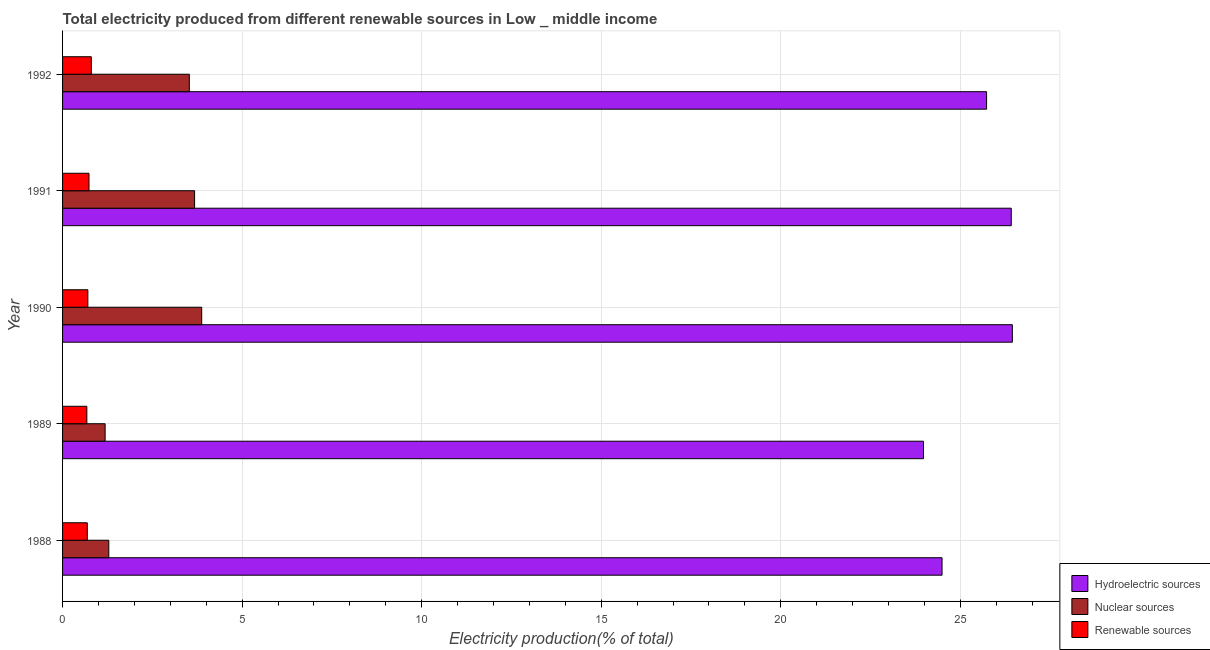How many bars are there on the 1st tick from the top?
Make the answer very short. 3. In how many cases, is the number of bars for a given year not equal to the number of legend labels?
Your answer should be very brief. 0. What is the percentage of electricity produced by hydroelectric sources in 1991?
Give a very brief answer. 26.42. Across all years, what is the maximum percentage of electricity produced by hydroelectric sources?
Keep it short and to the point. 26.45. Across all years, what is the minimum percentage of electricity produced by hydroelectric sources?
Offer a terse response. 23.98. What is the total percentage of electricity produced by hydroelectric sources in the graph?
Ensure brevity in your answer.  127.07. What is the difference between the percentage of electricity produced by nuclear sources in 1988 and that in 1992?
Offer a very short reply. -2.24. What is the difference between the percentage of electricity produced by nuclear sources in 1991 and the percentage of electricity produced by hydroelectric sources in 1988?
Provide a short and direct response. -20.82. What is the average percentage of electricity produced by hydroelectric sources per year?
Offer a very short reply. 25.41. In the year 1992, what is the difference between the percentage of electricity produced by hydroelectric sources and percentage of electricity produced by nuclear sources?
Your answer should be compact. 22.2. In how many years, is the percentage of electricity produced by nuclear sources greater than 15 %?
Offer a terse response. 0. What is the ratio of the percentage of electricity produced by nuclear sources in 1988 to that in 1991?
Give a very brief answer. 0.35. What is the difference between the highest and the second highest percentage of electricity produced by nuclear sources?
Your answer should be compact. 0.2. What is the difference between the highest and the lowest percentage of electricity produced by renewable sources?
Offer a very short reply. 0.12. In how many years, is the percentage of electricity produced by hydroelectric sources greater than the average percentage of electricity produced by hydroelectric sources taken over all years?
Give a very brief answer. 3. Is the sum of the percentage of electricity produced by renewable sources in 1990 and 1992 greater than the maximum percentage of electricity produced by nuclear sources across all years?
Provide a short and direct response. No. What does the 3rd bar from the top in 1990 represents?
Provide a short and direct response. Hydroelectric sources. What does the 2nd bar from the bottom in 1988 represents?
Offer a very short reply. Nuclear sources. Are all the bars in the graph horizontal?
Offer a very short reply. Yes. Are the values on the major ticks of X-axis written in scientific E-notation?
Offer a terse response. No. Does the graph contain any zero values?
Keep it short and to the point. No. Does the graph contain grids?
Your answer should be very brief. Yes. Where does the legend appear in the graph?
Keep it short and to the point. Bottom right. How are the legend labels stacked?
Provide a succinct answer. Vertical. What is the title of the graph?
Offer a very short reply. Total electricity produced from different renewable sources in Low _ middle income. What is the label or title of the X-axis?
Offer a very short reply. Electricity production(% of total). What is the label or title of the Y-axis?
Offer a very short reply. Year. What is the Electricity production(% of total) in Hydroelectric sources in 1988?
Your response must be concise. 24.49. What is the Electricity production(% of total) of Nuclear sources in 1988?
Your answer should be very brief. 1.29. What is the Electricity production(% of total) in Renewable sources in 1988?
Offer a terse response. 0.69. What is the Electricity production(% of total) of Hydroelectric sources in 1989?
Give a very brief answer. 23.98. What is the Electricity production(% of total) in Nuclear sources in 1989?
Offer a terse response. 1.19. What is the Electricity production(% of total) of Renewable sources in 1989?
Your response must be concise. 0.68. What is the Electricity production(% of total) in Hydroelectric sources in 1990?
Ensure brevity in your answer.  26.45. What is the Electricity production(% of total) of Nuclear sources in 1990?
Offer a terse response. 3.87. What is the Electricity production(% of total) of Renewable sources in 1990?
Make the answer very short. 0.7. What is the Electricity production(% of total) of Hydroelectric sources in 1991?
Provide a succinct answer. 26.42. What is the Electricity production(% of total) of Nuclear sources in 1991?
Offer a very short reply. 3.68. What is the Electricity production(% of total) of Renewable sources in 1991?
Provide a short and direct response. 0.74. What is the Electricity production(% of total) in Hydroelectric sources in 1992?
Provide a succinct answer. 25.73. What is the Electricity production(% of total) in Nuclear sources in 1992?
Your answer should be very brief. 3.53. What is the Electricity production(% of total) in Renewable sources in 1992?
Your response must be concise. 0.8. Across all years, what is the maximum Electricity production(% of total) of Hydroelectric sources?
Ensure brevity in your answer.  26.45. Across all years, what is the maximum Electricity production(% of total) in Nuclear sources?
Keep it short and to the point. 3.87. Across all years, what is the maximum Electricity production(% of total) of Renewable sources?
Provide a short and direct response. 0.8. Across all years, what is the minimum Electricity production(% of total) of Hydroelectric sources?
Ensure brevity in your answer.  23.98. Across all years, what is the minimum Electricity production(% of total) of Nuclear sources?
Your answer should be very brief. 1.19. Across all years, what is the minimum Electricity production(% of total) of Renewable sources?
Your answer should be very brief. 0.68. What is the total Electricity production(% of total) in Hydroelectric sources in the graph?
Ensure brevity in your answer.  127.07. What is the total Electricity production(% of total) of Nuclear sources in the graph?
Provide a succinct answer. 13.55. What is the total Electricity production(% of total) of Renewable sources in the graph?
Offer a terse response. 3.61. What is the difference between the Electricity production(% of total) of Hydroelectric sources in 1988 and that in 1989?
Give a very brief answer. 0.52. What is the difference between the Electricity production(% of total) of Nuclear sources in 1988 and that in 1989?
Keep it short and to the point. 0.1. What is the difference between the Electricity production(% of total) in Renewable sources in 1988 and that in 1989?
Your answer should be very brief. 0.01. What is the difference between the Electricity production(% of total) of Hydroelectric sources in 1988 and that in 1990?
Make the answer very short. -1.96. What is the difference between the Electricity production(% of total) in Nuclear sources in 1988 and that in 1990?
Provide a short and direct response. -2.59. What is the difference between the Electricity production(% of total) in Renewable sources in 1988 and that in 1990?
Offer a terse response. -0.02. What is the difference between the Electricity production(% of total) of Hydroelectric sources in 1988 and that in 1991?
Your answer should be very brief. -1.93. What is the difference between the Electricity production(% of total) in Nuclear sources in 1988 and that in 1991?
Give a very brief answer. -2.39. What is the difference between the Electricity production(% of total) of Renewable sources in 1988 and that in 1991?
Provide a short and direct response. -0.05. What is the difference between the Electricity production(% of total) in Hydroelectric sources in 1988 and that in 1992?
Keep it short and to the point. -1.24. What is the difference between the Electricity production(% of total) of Nuclear sources in 1988 and that in 1992?
Provide a succinct answer. -2.24. What is the difference between the Electricity production(% of total) of Renewable sources in 1988 and that in 1992?
Keep it short and to the point. -0.11. What is the difference between the Electricity production(% of total) in Hydroelectric sources in 1989 and that in 1990?
Make the answer very short. -2.48. What is the difference between the Electricity production(% of total) of Nuclear sources in 1989 and that in 1990?
Keep it short and to the point. -2.69. What is the difference between the Electricity production(% of total) in Renewable sources in 1989 and that in 1990?
Give a very brief answer. -0.03. What is the difference between the Electricity production(% of total) in Hydroelectric sources in 1989 and that in 1991?
Offer a very short reply. -2.44. What is the difference between the Electricity production(% of total) of Nuclear sources in 1989 and that in 1991?
Your response must be concise. -2.49. What is the difference between the Electricity production(% of total) of Renewable sources in 1989 and that in 1991?
Offer a very short reply. -0.06. What is the difference between the Electricity production(% of total) of Hydroelectric sources in 1989 and that in 1992?
Offer a very short reply. -1.76. What is the difference between the Electricity production(% of total) in Nuclear sources in 1989 and that in 1992?
Make the answer very short. -2.35. What is the difference between the Electricity production(% of total) of Renewable sources in 1989 and that in 1992?
Your answer should be compact. -0.12. What is the difference between the Electricity production(% of total) in Hydroelectric sources in 1990 and that in 1991?
Make the answer very short. 0.03. What is the difference between the Electricity production(% of total) of Nuclear sources in 1990 and that in 1991?
Ensure brevity in your answer.  0.2. What is the difference between the Electricity production(% of total) of Renewable sources in 1990 and that in 1991?
Give a very brief answer. -0.03. What is the difference between the Electricity production(% of total) of Hydroelectric sources in 1990 and that in 1992?
Provide a short and direct response. 0.72. What is the difference between the Electricity production(% of total) in Nuclear sources in 1990 and that in 1992?
Provide a short and direct response. 0.34. What is the difference between the Electricity production(% of total) of Renewable sources in 1990 and that in 1992?
Ensure brevity in your answer.  -0.1. What is the difference between the Electricity production(% of total) of Hydroelectric sources in 1991 and that in 1992?
Ensure brevity in your answer.  0.69. What is the difference between the Electricity production(% of total) of Nuclear sources in 1991 and that in 1992?
Provide a short and direct response. 0.15. What is the difference between the Electricity production(% of total) of Renewable sources in 1991 and that in 1992?
Provide a short and direct response. -0.06. What is the difference between the Electricity production(% of total) of Hydroelectric sources in 1988 and the Electricity production(% of total) of Nuclear sources in 1989?
Ensure brevity in your answer.  23.31. What is the difference between the Electricity production(% of total) in Hydroelectric sources in 1988 and the Electricity production(% of total) in Renewable sources in 1989?
Provide a short and direct response. 23.82. What is the difference between the Electricity production(% of total) in Nuclear sources in 1988 and the Electricity production(% of total) in Renewable sources in 1989?
Give a very brief answer. 0.61. What is the difference between the Electricity production(% of total) in Hydroelectric sources in 1988 and the Electricity production(% of total) in Nuclear sources in 1990?
Give a very brief answer. 20.62. What is the difference between the Electricity production(% of total) of Hydroelectric sources in 1988 and the Electricity production(% of total) of Renewable sources in 1990?
Ensure brevity in your answer.  23.79. What is the difference between the Electricity production(% of total) of Nuclear sources in 1988 and the Electricity production(% of total) of Renewable sources in 1990?
Make the answer very short. 0.58. What is the difference between the Electricity production(% of total) of Hydroelectric sources in 1988 and the Electricity production(% of total) of Nuclear sources in 1991?
Keep it short and to the point. 20.82. What is the difference between the Electricity production(% of total) of Hydroelectric sources in 1988 and the Electricity production(% of total) of Renewable sources in 1991?
Your answer should be compact. 23.76. What is the difference between the Electricity production(% of total) in Nuclear sources in 1988 and the Electricity production(% of total) in Renewable sources in 1991?
Make the answer very short. 0.55. What is the difference between the Electricity production(% of total) in Hydroelectric sources in 1988 and the Electricity production(% of total) in Nuclear sources in 1992?
Provide a short and direct response. 20.96. What is the difference between the Electricity production(% of total) of Hydroelectric sources in 1988 and the Electricity production(% of total) of Renewable sources in 1992?
Give a very brief answer. 23.69. What is the difference between the Electricity production(% of total) in Nuclear sources in 1988 and the Electricity production(% of total) in Renewable sources in 1992?
Make the answer very short. 0.49. What is the difference between the Electricity production(% of total) in Hydroelectric sources in 1989 and the Electricity production(% of total) in Nuclear sources in 1990?
Provide a short and direct response. 20.1. What is the difference between the Electricity production(% of total) of Hydroelectric sources in 1989 and the Electricity production(% of total) of Renewable sources in 1990?
Keep it short and to the point. 23.27. What is the difference between the Electricity production(% of total) in Nuclear sources in 1989 and the Electricity production(% of total) in Renewable sources in 1990?
Offer a terse response. 0.48. What is the difference between the Electricity production(% of total) of Hydroelectric sources in 1989 and the Electricity production(% of total) of Nuclear sources in 1991?
Keep it short and to the point. 20.3. What is the difference between the Electricity production(% of total) of Hydroelectric sources in 1989 and the Electricity production(% of total) of Renewable sources in 1991?
Keep it short and to the point. 23.24. What is the difference between the Electricity production(% of total) in Nuclear sources in 1989 and the Electricity production(% of total) in Renewable sources in 1991?
Make the answer very short. 0.45. What is the difference between the Electricity production(% of total) of Hydroelectric sources in 1989 and the Electricity production(% of total) of Nuclear sources in 1992?
Offer a very short reply. 20.45. What is the difference between the Electricity production(% of total) of Hydroelectric sources in 1989 and the Electricity production(% of total) of Renewable sources in 1992?
Give a very brief answer. 23.18. What is the difference between the Electricity production(% of total) in Nuclear sources in 1989 and the Electricity production(% of total) in Renewable sources in 1992?
Keep it short and to the point. 0.38. What is the difference between the Electricity production(% of total) of Hydroelectric sources in 1990 and the Electricity production(% of total) of Nuclear sources in 1991?
Keep it short and to the point. 22.77. What is the difference between the Electricity production(% of total) in Hydroelectric sources in 1990 and the Electricity production(% of total) in Renewable sources in 1991?
Provide a short and direct response. 25.72. What is the difference between the Electricity production(% of total) of Nuclear sources in 1990 and the Electricity production(% of total) of Renewable sources in 1991?
Offer a very short reply. 3.14. What is the difference between the Electricity production(% of total) in Hydroelectric sources in 1990 and the Electricity production(% of total) in Nuclear sources in 1992?
Provide a short and direct response. 22.92. What is the difference between the Electricity production(% of total) of Hydroelectric sources in 1990 and the Electricity production(% of total) of Renewable sources in 1992?
Give a very brief answer. 25.65. What is the difference between the Electricity production(% of total) of Nuclear sources in 1990 and the Electricity production(% of total) of Renewable sources in 1992?
Offer a terse response. 3.07. What is the difference between the Electricity production(% of total) of Hydroelectric sources in 1991 and the Electricity production(% of total) of Nuclear sources in 1992?
Make the answer very short. 22.89. What is the difference between the Electricity production(% of total) in Hydroelectric sources in 1991 and the Electricity production(% of total) in Renewable sources in 1992?
Offer a very short reply. 25.62. What is the difference between the Electricity production(% of total) in Nuclear sources in 1991 and the Electricity production(% of total) in Renewable sources in 1992?
Offer a terse response. 2.88. What is the average Electricity production(% of total) of Hydroelectric sources per year?
Ensure brevity in your answer.  25.41. What is the average Electricity production(% of total) of Nuclear sources per year?
Keep it short and to the point. 2.71. What is the average Electricity production(% of total) in Renewable sources per year?
Give a very brief answer. 0.72. In the year 1988, what is the difference between the Electricity production(% of total) of Hydroelectric sources and Electricity production(% of total) of Nuclear sources?
Your answer should be very brief. 23.21. In the year 1988, what is the difference between the Electricity production(% of total) of Hydroelectric sources and Electricity production(% of total) of Renewable sources?
Keep it short and to the point. 23.8. In the year 1988, what is the difference between the Electricity production(% of total) in Nuclear sources and Electricity production(% of total) in Renewable sources?
Offer a very short reply. 0.6. In the year 1989, what is the difference between the Electricity production(% of total) of Hydroelectric sources and Electricity production(% of total) of Nuclear sources?
Ensure brevity in your answer.  22.79. In the year 1989, what is the difference between the Electricity production(% of total) of Hydroelectric sources and Electricity production(% of total) of Renewable sources?
Your response must be concise. 23.3. In the year 1989, what is the difference between the Electricity production(% of total) in Nuclear sources and Electricity production(% of total) in Renewable sources?
Offer a very short reply. 0.51. In the year 1990, what is the difference between the Electricity production(% of total) of Hydroelectric sources and Electricity production(% of total) of Nuclear sources?
Offer a very short reply. 22.58. In the year 1990, what is the difference between the Electricity production(% of total) in Hydroelectric sources and Electricity production(% of total) in Renewable sources?
Offer a terse response. 25.75. In the year 1990, what is the difference between the Electricity production(% of total) of Nuclear sources and Electricity production(% of total) of Renewable sources?
Provide a short and direct response. 3.17. In the year 1991, what is the difference between the Electricity production(% of total) in Hydroelectric sources and Electricity production(% of total) in Nuclear sources?
Make the answer very short. 22.74. In the year 1991, what is the difference between the Electricity production(% of total) in Hydroelectric sources and Electricity production(% of total) in Renewable sources?
Your answer should be compact. 25.68. In the year 1991, what is the difference between the Electricity production(% of total) of Nuclear sources and Electricity production(% of total) of Renewable sources?
Keep it short and to the point. 2.94. In the year 1992, what is the difference between the Electricity production(% of total) in Hydroelectric sources and Electricity production(% of total) in Nuclear sources?
Your response must be concise. 22.2. In the year 1992, what is the difference between the Electricity production(% of total) of Hydroelectric sources and Electricity production(% of total) of Renewable sources?
Your answer should be very brief. 24.93. In the year 1992, what is the difference between the Electricity production(% of total) in Nuclear sources and Electricity production(% of total) in Renewable sources?
Provide a succinct answer. 2.73. What is the ratio of the Electricity production(% of total) of Hydroelectric sources in 1988 to that in 1989?
Provide a short and direct response. 1.02. What is the ratio of the Electricity production(% of total) in Nuclear sources in 1988 to that in 1989?
Your answer should be compact. 1.09. What is the ratio of the Electricity production(% of total) in Renewable sources in 1988 to that in 1989?
Give a very brief answer. 1.02. What is the ratio of the Electricity production(% of total) of Hydroelectric sources in 1988 to that in 1990?
Provide a short and direct response. 0.93. What is the ratio of the Electricity production(% of total) in Nuclear sources in 1988 to that in 1990?
Offer a terse response. 0.33. What is the ratio of the Electricity production(% of total) of Renewable sources in 1988 to that in 1990?
Provide a succinct answer. 0.98. What is the ratio of the Electricity production(% of total) of Hydroelectric sources in 1988 to that in 1991?
Keep it short and to the point. 0.93. What is the ratio of the Electricity production(% of total) of Nuclear sources in 1988 to that in 1991?
Your answer should be very brief. 0.35. What is the ratio of the Electricity production(% of total) in Renewable sources in 1988 to that in 1991?
Give a very brief answer. 0.94. What is the ratio of the Electricity production(% of total) of Hydroelectric sources in 1988 to that in 1992?
Ensure brevity in your answer.  0.95. What is the ratio of the Electricity production(% of total) in Nuclear sources in 1988 to that in 1992?
Ensure brevity in your answer.  0.36. What is the ratio of the Electricity production(% of total) in Renewable sources in 1988 to that in 1992?
Give a very brief answer. 0.86. What is the ratio of the Electricity production(% of total) of Hydroelectric sources in 1989 to that in 1990?
Your response must be concise. 0.91. What is the ratio of the Electricity production(% of total) in Nuclear sources in 1989 to that in 1990?
Provide a short and direct response. 0.31. What is the ratio of the Electricity production(% of total) of Renewable sources in 1989 to that in 1990?
Your response must be concise. 0.96. What is the ratio of the Electricity production(% of total) in Hydroelectric sources in 1989 to that in 1991?
Make the answer very short. 0.91. What is the ratio of the Electricity production(% of total) of Nuclear sources in 1989 to that in 1991?
Your answer should be very brief. 0.32. What is the ratio of the Electricity production(% of total) of Renewable sources in 1989 to that in 1991?
Ensure brevity in your answer.  0.92. What is the ratio of the Electricity production(% of total) of Hydroelectric sources in 1989 to that in 1992?
Your response must be concise. 0.93. What is the ratio of the Electricity production(% of total) of Nuclear sources in 1989 to that in 1992?
Provide a short and direct response. 0.34. What is the ratio of the Electricity production(% of total) in Renewable sources in 1989 to that in 1992?
Offer a terse response. 0.84. What is the ratio of the Electricity production(% of total) of Nuclear sources in 1990 to that in 1991?
Offer a terse response. 1.05. What is the ratio of the Electricity production(% of total) of Renewable sources in 1990 to that in 1991?
Give a very brief answer. 0.96. What is the ratio of the Electricity production(% of total) of Hydroelectric sources in 1990 to that in 1992?
Your response must be concise. 1.03. What is the ratio of the Electricity production(% of total) of Nuclear sources in 1990 to that in 1992?
Keep it short and to the point. 1.1. What is the ratio of the Electricity production(% of total) of Renewable sources in 1990 to that in 1992?
Offer a terse response. 0.88. What is the ratio of the Electricity production(% of total) of Hydroelectric sources in 1991 to that in 1992?
Your answer should be very brief. 1.03. What is the ratio of the Electricity production(% of total) of Nuclear sources in 1991 to that in 1992?
Provide a short and direct response. 1.04. What is the ratio of the Electricity production(% of total) of Renewable sources in 1991 to that in 1992?
Give a very brief answer. 0.92. What is the difference between the highest and the second highest Electricity production(% of total) of Hydroelectric sources?
Your answer should be compact. 0.03. What is the difference between the highest and the second highest Electricity production(% of total) of Nuclear sources?
Offer a very short reply. 0.2. What is the difference between the highest and the second highest Electricity production(% of total) of Renewable sources?
Your answer should be very brief. 0.06. What is the difference between the highest and the lowest Electricity production(% of total) of Hydroelectric sources?
Offer a very short reply. 2.48. What is the difference between the highest and the lowest Electricity production(% of total) in Nuclear sources?
Make the answer very short. 2.69. What is the difference between the highest and the lowest Electricity production(% of total) of Renewable sources?
Make the answer very short. 0.12. 